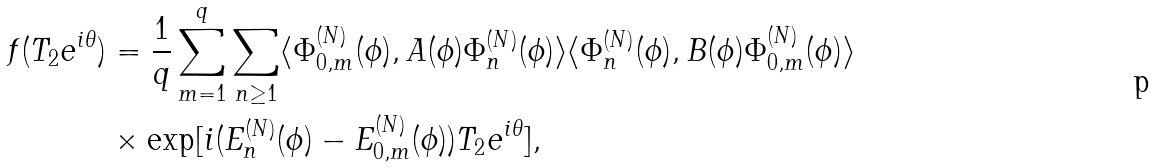Convert formula to latex. <formula><loc_0><loc_0><loc_500><loc_500>f ( T _ { 2 } e ^ { i \theta } ) & = \frac { 1 } { q } \sum _ { m = 1 } ^ { q } \sum _ { n \geq 1 } \langle \Phi _ { 0 , m } ^ { ( N ) } ( \phi ) , A ( \phi ) \Phi _ { n } ^ { ( N ) } ( \phi ) \rangle \langle \Phi _ { n } ^ { ( N ) } ( \phi ) , B ( \phi ) \Phi _ { 0 , m } ^ { ( N ) } ( \phi ) \rangle \\ & \times \exp [ i ( E _ { n } ^ { ( N ) } ( \phi ) - E _ { 0 , m } ^ { ( N ) } ( \phi ) ) T _ { 2 } e ^ { i \theta } ] ,</formula> 